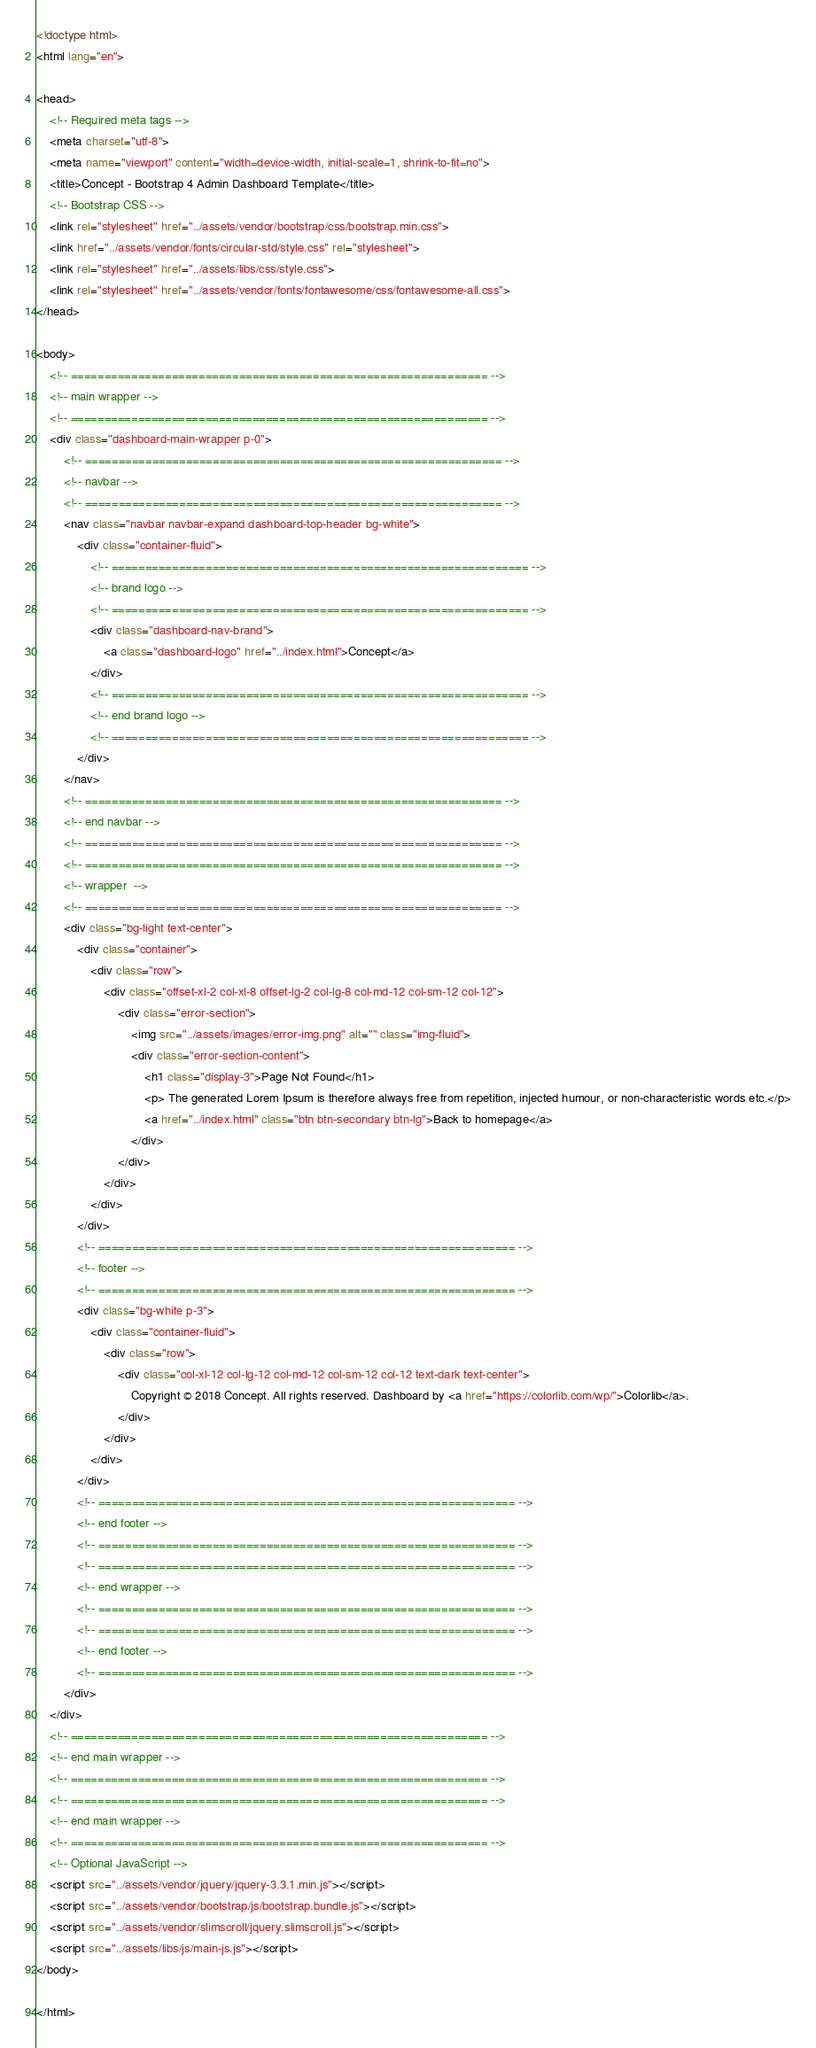Convert code to text. <code><loc_0><loc_0><loc_500><loc_500><_HTML_><!doctype html>
<html lang="en">
 
<head>
    <!-- Required meta tags -->
    <meta charset="utf-8">
    <meta name="viewport" content="width=device-width, initial-scale=1, shrink-to-fit=no">
    <title>Concept - Bootstrap 4 Admin Dashboard Template</title>
    <!-- Bootstrap CSS -->
    <link rel="stylesheet" href="../assets/vendor/bootstrap/css/bootstrap.min.css">
    <link href="../assets/vendor/fonts/circular-std/style.css" rel="stylesheet">
    <link rel="stylesheet" href="../assets/libs/css/style.css">
    <link rel="stylesheet" href="../assets/vendor/fonts/fontawesome/css/fontawesome-all.css">
</head>

<body>
    <!-- ============================================================== -->
    <!-- main wrapper -->
    <!-- ============================================================== -->
    <div class="dashboard-main-wrapper p-0">
        <!-- ============================================================== -->
        <!-- navbar -->
        <!-- ============================================================== -->
        <nav class="navbar navbar-expand dashboard-top-header bg-white">
            <div class="container-fluid">
                <!-- ============================================================== -->
                <!-- brand logo -->
                <!-- ============================================================== -->
                <div class="dashboard-nav-brand">
                    <a class="dashboard-logo" href="../index.html">Concept</a>
                </div>
                <!-- ============================================================== -->
                <!-- end brand logo -->
                <!-- ============================================================== -->
            </div>
        </nav>
        <!-- ============================================================== -->
        <!-- end navbar -->
        <!-- ============================================================== -->
        <!-- ============================================================== -->
        <!-- wrapper  -->
        <!-- ============================================================== -->
        <div class="bg-light text-center">
            <div class="container">
                <div class="row">
                    <div class="offset-xl-2 col-xl-8 offset-lg-2 col-lg-8 col-md-12 col-sm-12 col-12">
                        <div class="error-section">
                            <img src="../assets/images/error-img.png" alt="" class="img-fluid">
                            <div class="error-section-content">
                                <h1 class="display-3">Page Not Found</h1>
                                <p> The generated Lorem Ipsum is therefore always free from repetition, injected humour, or non-characteristic words etc.</p>
                                <a href="../index.html" class="btn btn-secondary btn-lg">Back to homepage</a>
                            </div>
                        </div>
                    </div>
                </div>
            </div>
            <!-- ============================================================== -->
            <!-- footer -->
            <!-- ============================================================== -->
            <div class="bg-white p-3">
                <div class="container-fluid">
                    <div class="row">
                        <div class="col-xl-12 col-lg-12 col-md-12 col-sm-12 col-12 text-dark text-center">
                            Copyright © 2018 Concept. All rights reserved. Dashboard by <a href="https://colorlib.com/wp/">Colorlib</a>.
                        </div>
                    </div>
                </div>
            </div>
            <!-- ============================================================== -->
            <!-- end footer -->
            <!-- ============================================================== -->
            <!-- ============================================================== -->
            <!-- end wrapper -->
            <!-- ============================================================== -->
            <!-- ============================================================== -->
            <!-- end footer -->
            <!-- ============================================================== -->
        </div>
    </div>
    <!-- ============================================================== -->
    <!-- end main wrapper -->
    <!-- ============================================================== -->
    <!-- ============================================================== -->
    <!-- end main wrapper -->
    <!-- ============================================================== -->
    <!-- Optional JavaScript -->
    <script src="../assets/vendor/jquery/jquery-3.3.1.min.js"></script>
    <script src="../assets/vendor/bootstrap/js/bootstrap.bundle.js"></script>
    <script src="../assets/vendor/slimscroll/jquery.slimscroll.js"></script>
    <script src="../assets/libs/js/main-js.js"></script>
</body>
 
</html></code> 